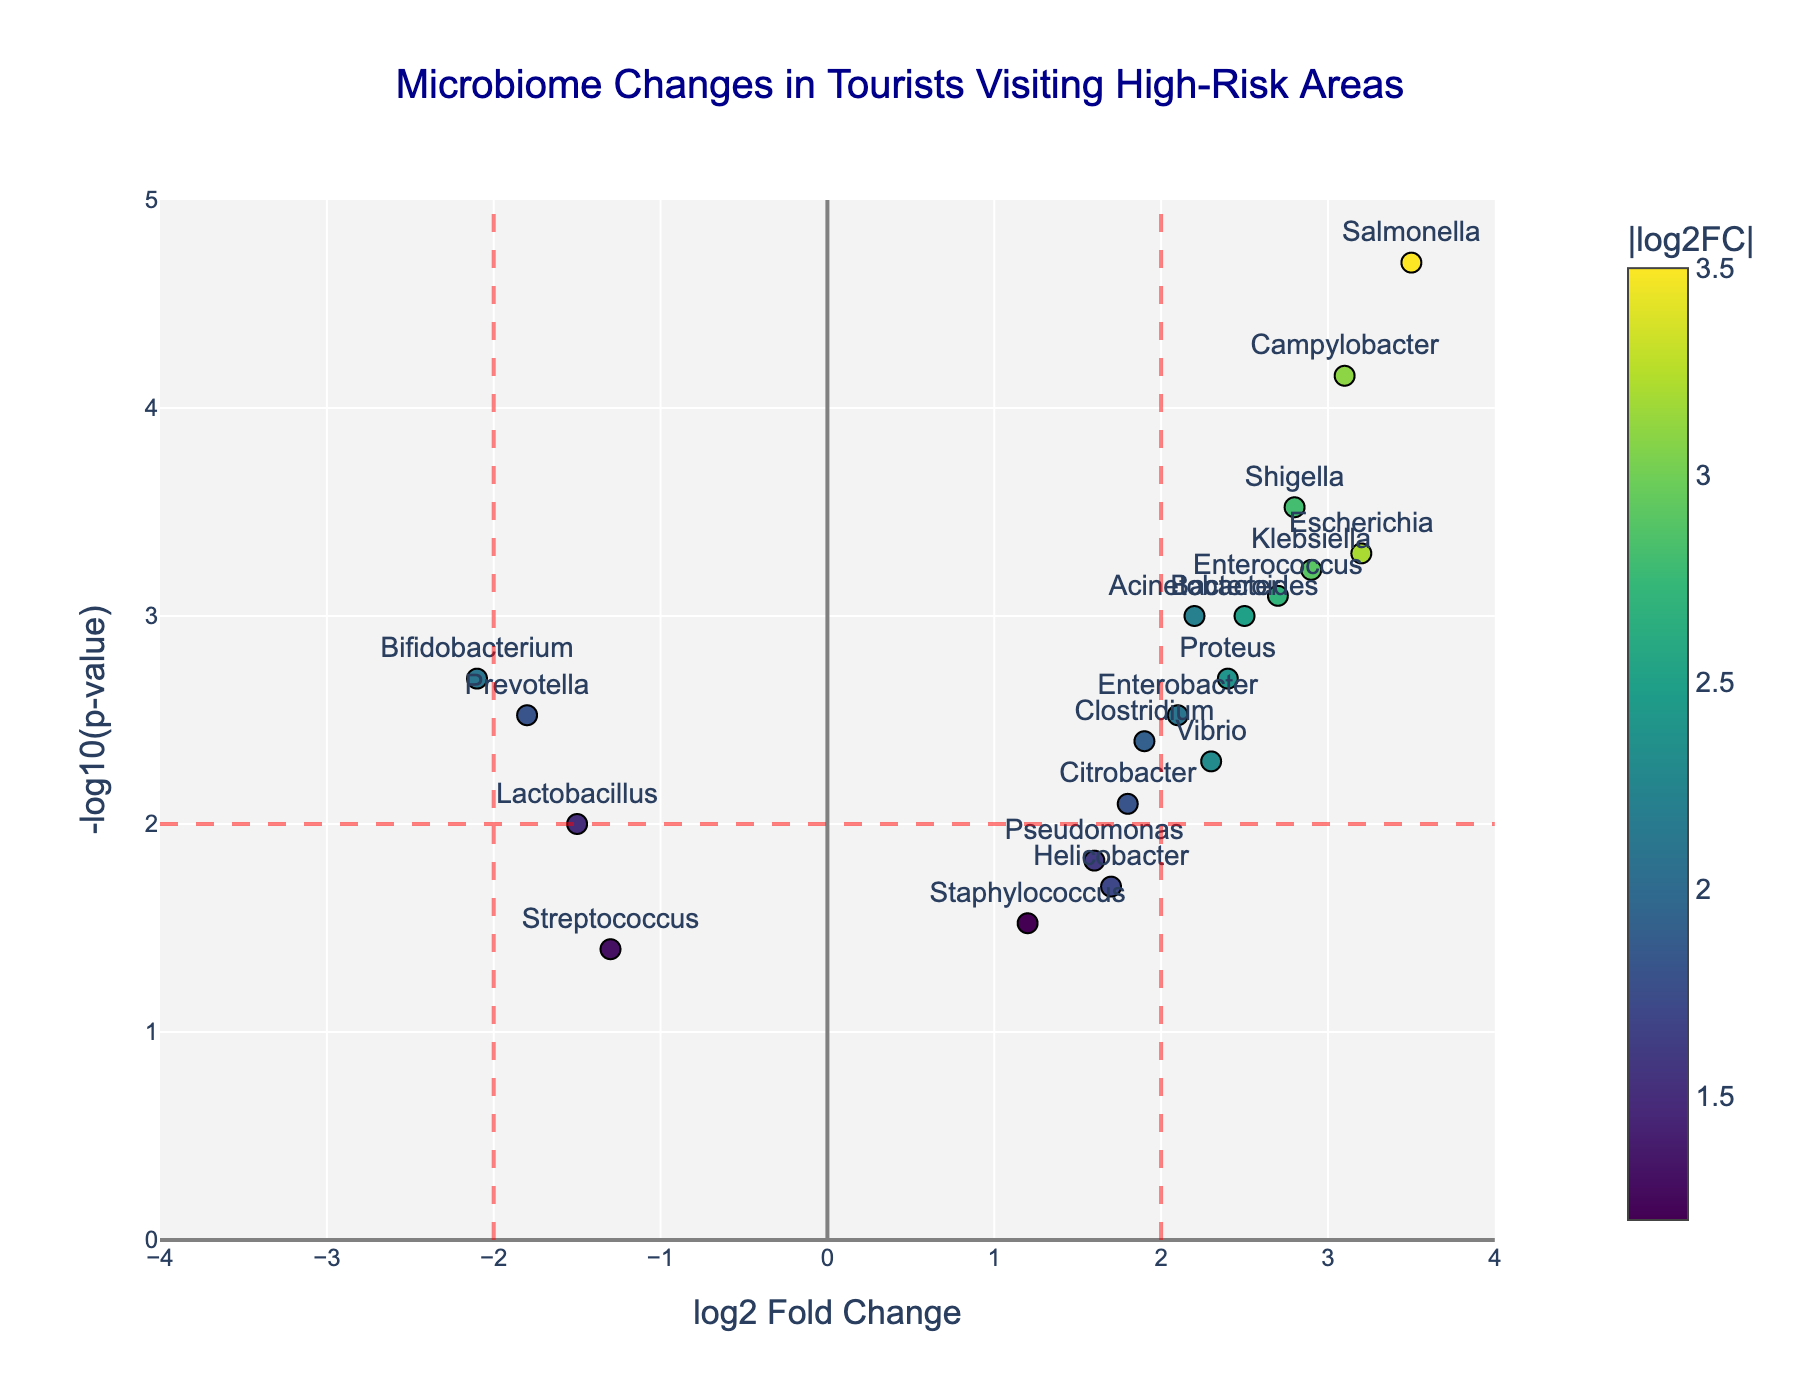What's the title of the figure? The title of the figure is clearly stated at the top. It reads "Microbiome Changes in Tourists Visiting High-Risk Areas."
Answer: Microbiome Changes in Tourists Visiting High-Risk Areas What are the axes titles of the plot? The x-axis title is "log2 Fold Change" and the y-axis title is "-log10(p-value)."
Answer: log2 Fold Change and -log10(p-value) How many genes have a log2 fold change greater than 2? Genes with a log2 fold change greater than 2 are located to the right of the vertical red dashed line at x=2. The genes are 7 in total: Escherichia, Enterococcus, Salmonella, Shigella, Campylobacter, Klebsiella, and Proteus.
Answer: 7 Which gene has the highest log2 fold change? By looking at the x-axis, we identify the gene at the farthest right. This gene is Salmonella with a log2 fold change of 3.5.
Answer: Salmonella Which gene has the lowest p-value? The lowest p-value corresponds to the highest -log10(p-value) on the y-axis. The gene at the highest point on the y-axis is Salmonella with a -log10(p-value) of around 4.7.
Answer: Salmonella Which gene has a log2 fold change nearly at the central point (0 log2 Fold Change)? The gene closest to the central point (0,0) on the plot is Staphylococcus with a log2 fold change of 1.2 and is relatively near to the x=0 line.
Answer: Staphylococcus Which genes show a significant decrease in abundance (negative log2 fold change) and are below the p-value threshold of 0.01? Genes with negative log2 fold changes that have a -log10(p-value) above the horizontal red dashed line (p-value < 0.01) include Prevotella and Bifidobacterium.
Answer: Prevotella and Bifidobacterium Are there more genes with increased abundance (positive log2 fold change) or decreased abundance (negative log2 fold change)? Count the number of genes on the right side (positive log2 fold change) and the left side (negative log2 fold change) of x=0. There are more genes with increased abundance (positive log2 fold change).
Answer: Increased abundance Which genes are highlighted in green? Hovering over the markers labeled with the names and a colorscale from the legend shows that the colors change with log2 fold change. The genes with the least fold changes are shown in green. This includes Staphylococcus and Streptococcus.
Answer: Staphylococcus and Streptococcus 